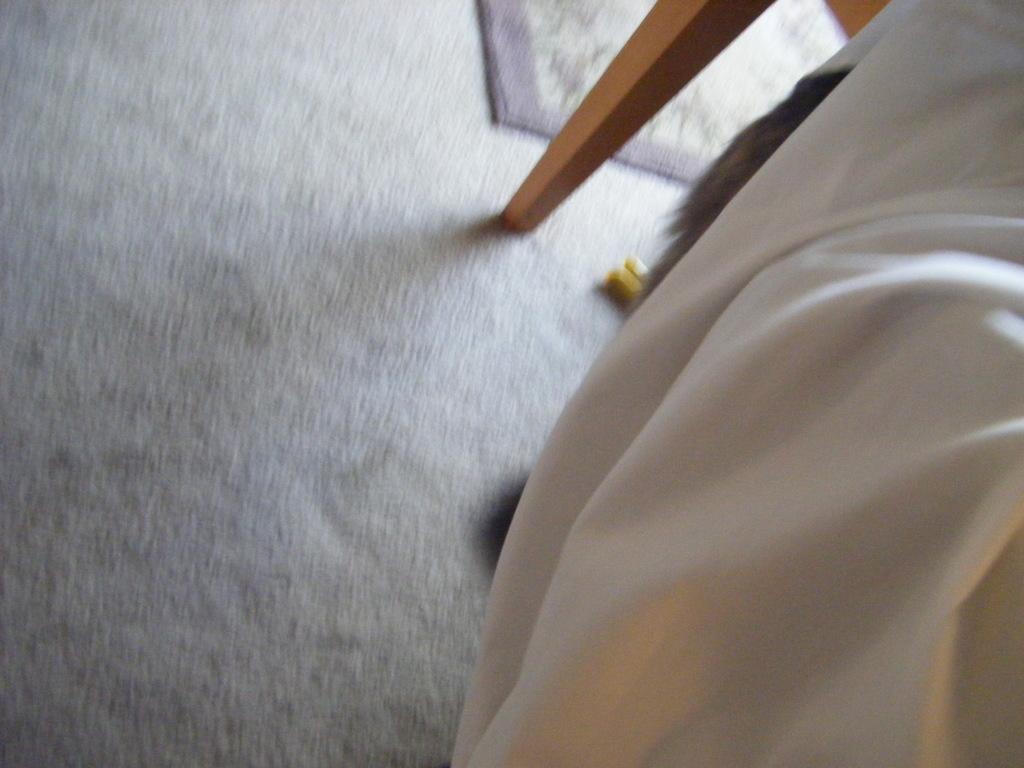In one or two sentences, can you explain what this image depicts? This picture is blur, in this picture we can see cloth, mat on the floor and objects. 